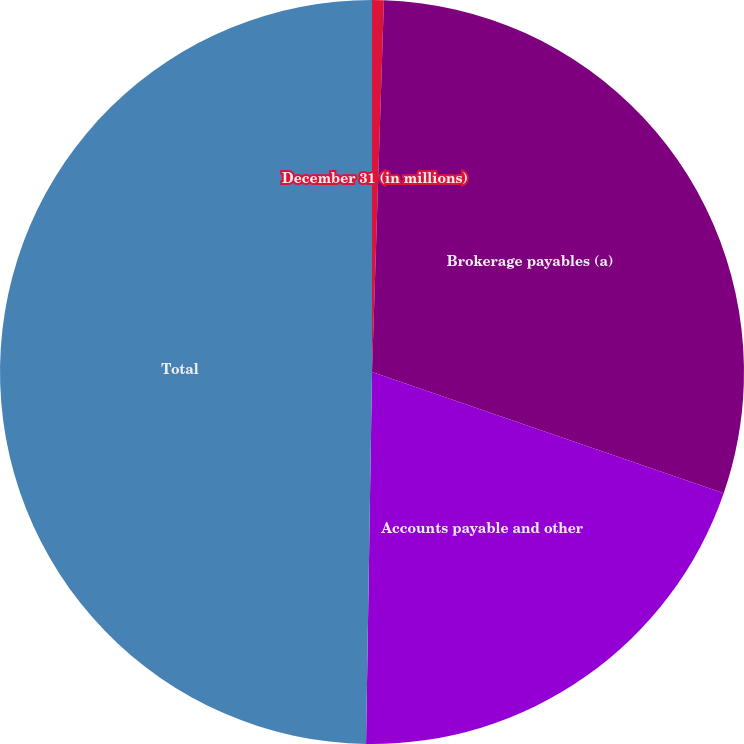<chart> <loc_0><loc_0><loc_500><loc_500><pie_chart><fcel>December 31 (in millions)<fcel>Brokerage payables (a)<fcel>Accounts payable and other<fcel>Total<nl><fcel>0.51%<fcel>29.77%<fcel>19.97%<fcel>49.74%<nl></chart> 